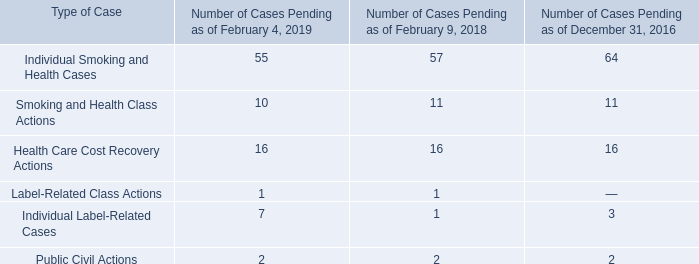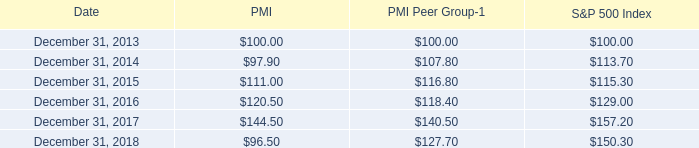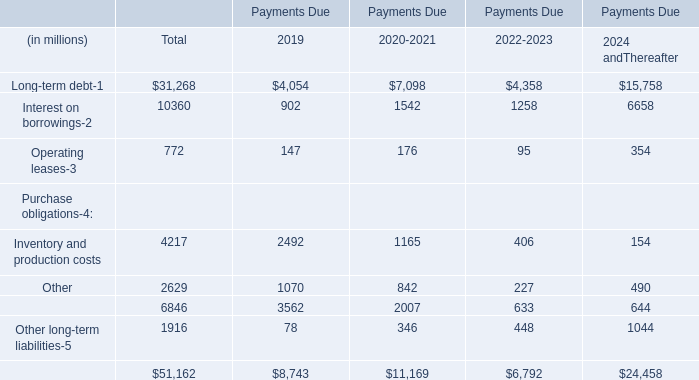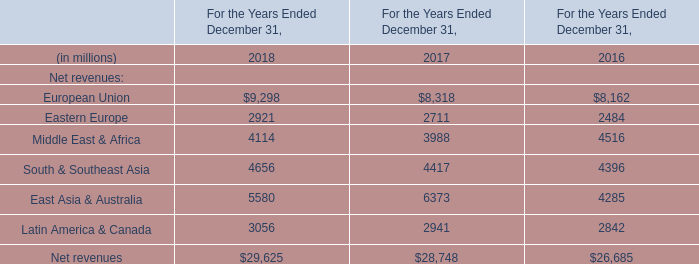How much is the Payments Due 2019 for Operating leases more than the Payments Due 2019 for Other long-term liabilities? (in million) 
Computations: (147 - 78)
Answer: 69.0. 